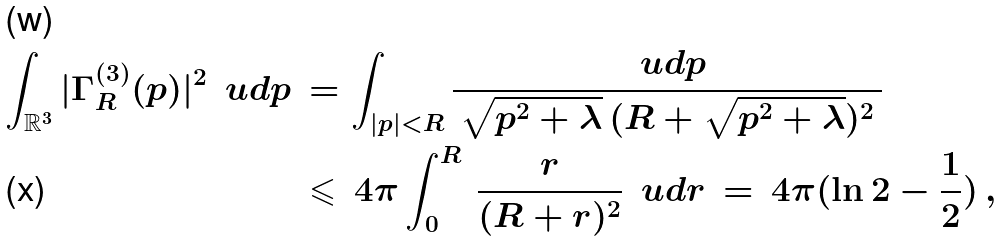Convert formula to latex. <formula><loc_0><loc_0><loc_500><loc_500>\int _ { \mathbb { R } ^ { 3 } } | \Gamma _ { R } ^ { ( 3 ) } ( p ) | ^ { 2 } \, \ u d p \, & = \int _ { | p | < R } \frac { \ u d p } { \, \sqrt { p ^ { 2 } + \lambda } \, ( R + \sqrt { p ^ { 2 } + \lambda } ) ^ { 2 } \, } \\ & \leqslant \, 4 \pi \int _ { 0 } ^ { R } \, \frac { r } { ( R + r ) ^ { 2 } } \, \ u d r \, = \, 4 \pi ( \ln 2 - { \frac { 1 } { 2 } } ) \, ,</formula> 